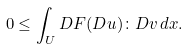<formula> <loc_0><loc_0><loc_500><loc_500>0 \leq \int _ { U } D F ( D u ) \colon D v \, d x .</formula> 